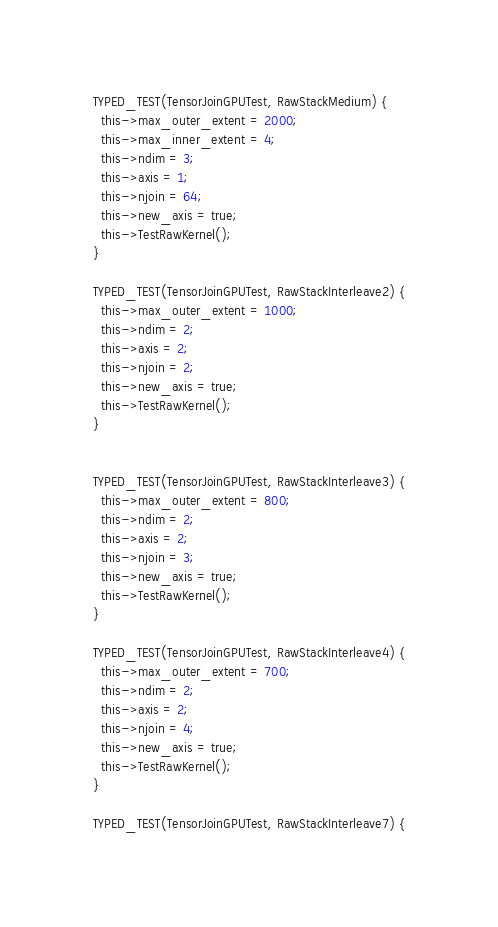<code> <loc_0><loc_0><loc_500><loc_500><_Cuda_>
TYPED_TEST(TensorJoinGPUTest, RawStackMedium) {
  this->max_outer_extent = 2000;
  this->max_inner_extent = 4;
  this->ndim = 3;
  this->axis = 1;
  this->njoin = 64;
  this->new_axis = true;
  this->TestRawKernel();
}

TYPED_TEST(TensorJoinGPUTest, RawStackInterleave2) {
  this->max_outer_extent = 1000;
  this->ndim = 2;
  this->axis = 2;
  this->njoin = 2;
  this->new_axis = true;
  this->TestRawKernel();
}


TYPED_TEST(TensorJoinGPUTest, RawStackInterleave3) {
  this->max_outer_extent = 800;
  this->ndim = 2;
  this->axis = 2;
  this->njoin = 3;
  this->new_axis = true;
  this->TestRawKernel();
}

TYPED_TEST(TensorJoinGPUTest, RawStackInterleave4) {
  this->max_outer_extent = 700;
  this->ndim = 2;
  this->axis = 2;
  this->njoin = 4;
  this->new_axis = true;
  this->TestRawKernel();
}

TYPED_TEST(TensorJoinGPUTest, RawStackInterleave7) {</code> 